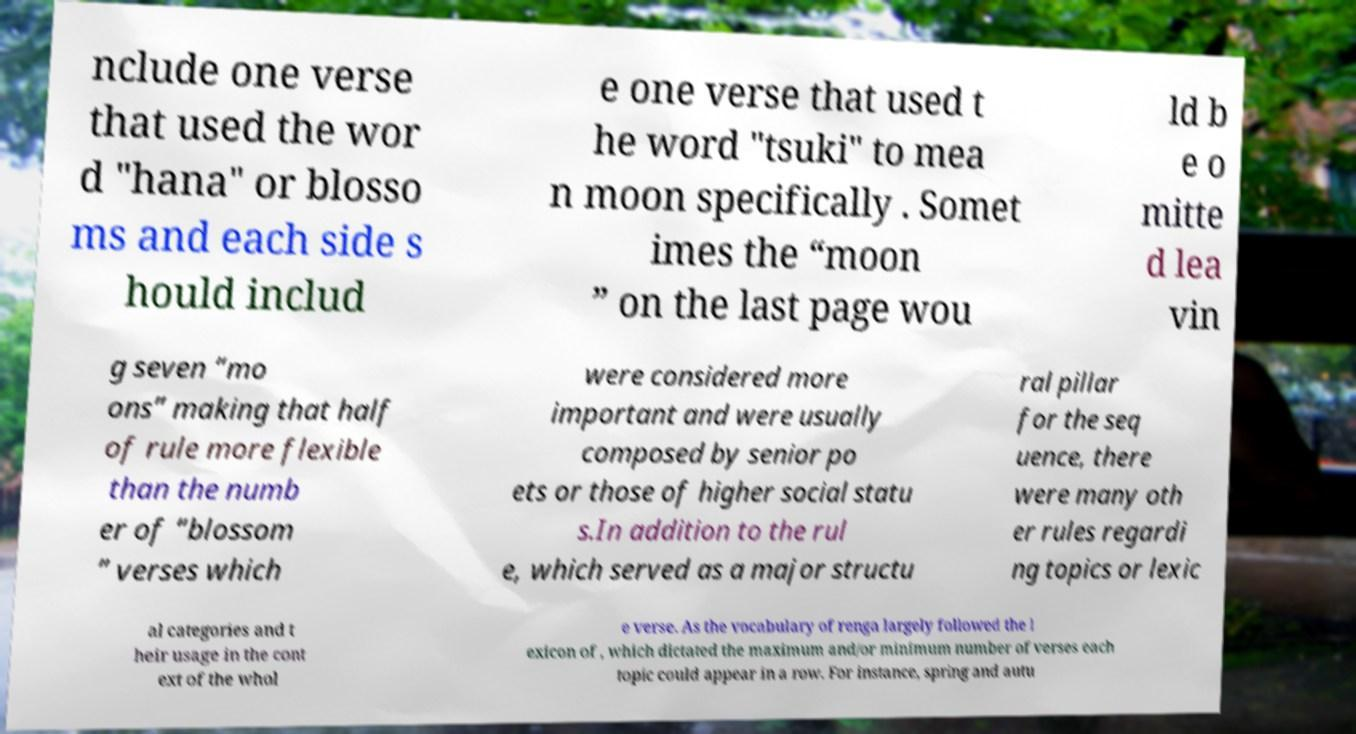Please read and relay the text visible in this image. What does it say? nclude one verse that used the wor d "hana" or blosso ms and each side s hould includ e one verse that used t he word "tsuki" to mea n moon specifically . Somet imes the “moon ” on the last page wou ld b e o mitte d lea vin g seven “mo ons” making that half of rule more flexible than the numb er of “blossom ” verses which were considered more important and were usually composed by senior po ets or those of higher social statu s.In addition to the rul e, which served as a major structu ral pillar for the seq uence, there were many oth er rules regardi ng topics or lexic al categories and t heir usage in the cont ext of the whol e verse. As the vocabulary of renga largely followed the l exicon of , which dictated the maximum and/or minimum number of verses each topic could appear in a row. For instance, spring and autu 